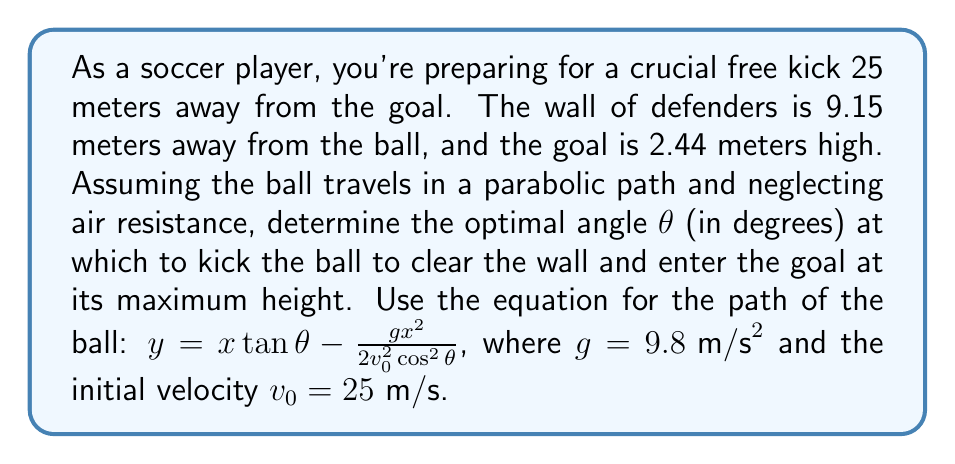Help me with this question. Let's approach this step-by-step:

1) First, we need to ensure the ball clears the wall. The wall is 9.15 meters away, so we'll use this as our x-coordinate. The standard height of players is about 1.8 meters, so we'll use 2 meters as the minimum height to clear the wall.

2) Substitute these values into our equation:

   $$2 = 9.15 \tan θ - \frac{9.8(9.15)^2}{2(25)^2 \cos^2 θ}$$

3) To find the maximum height at the goal, we need to find where $\frac{dy}{dx} = 0$. Taking the derivative of our original equation:

   $$\frac{dy}{dx} = \tan θ - \frac{gx}{v_0^2 \cos^2 θ}$$

4) Setting this equal to 0 and solving for x gives us the distance to the maximum height:

   $$x_{max} = \frac{v_0^2 \sin 2θ}{2g}$$

5) We want this maximum to occur at the goal, which is 25 meters away. So:

   $$25 = \frac{(25)^2 \sin 2θ}{2(9.8)}$$

6) Solving this equation:

   $$\sin 2θ = 0.784$$
   $$2θ = \arcsin(0.784) = 51.68°$$
   $$θ = 25.84°$$

7) Now, we need to check if this angle also satisfies clearing the wall. Substituting back into the equation from step 2:

   $$2 < 9.15 \tan(25.84°) - \frac{9.8(9.15)^2}{2(25)^2 \cos^2(25.84°)} = 4.36 \text{ meters}$$

   This confirms that the ball will clear the wall.

8) Finally, we can calculate the maximum height at the goal:

   $$y_{max} = 25 \tan(25.84°) - \frac{9.8(25)^2}{2(25)^2 \cos^2(25.84°)} = 5.68 \text{ meters}$$

   This is well above the goal height of 2.44 meters.
Answer: The optimal angle for the free kick is approximately 25.84°. 